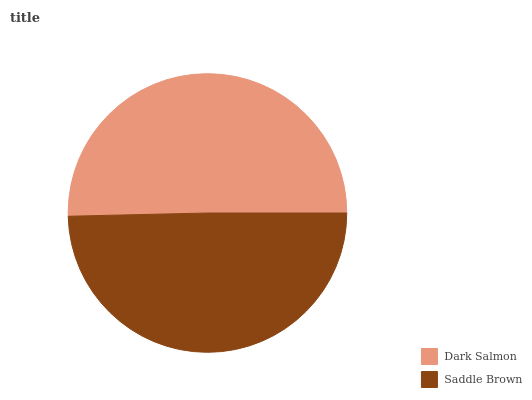Is Saddle Brown the minimum?
Answer yes or no. Yes. Is Dark Salmon the maximum?
Answer yes or no. Yes. Is Saddle Brown the maximum?
Answer yes or no. No. Is Dark Salmon greater than Saddle Brown?
Answer yes or no. Yes. Is Saddle Brown less than Dark Salmon?
Answer yes or no. Yes. Is Saddle Brown greater than Dark Salmon?
Answer yes or no. No. Is Dark Salmon less than Saddle Brown?
Answer yes or no. No. Is Dark Salmon the high median?
Answer yes or no. Yes. Is Saddle Brown the low median?
Answer yes or no. Yes. Is Saddle Brown the high median?
Answer yes or no. No. Is Dark Salmon the low median?
Answer yes or no. No. 